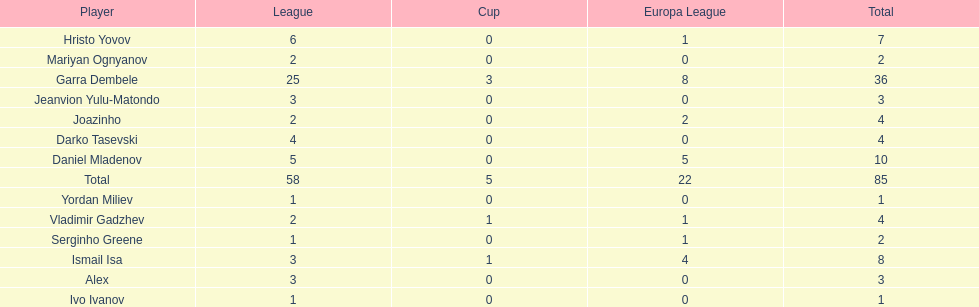Could you parse the entire table as a dict? {'header': ['Player', 'League', 'Cup', 'Europa League', 'Total'], 'rows': [['Hristo Yovov', '6', '0', '1', '7'], ['Mariyan Ognyanov', '2', '0', '0', '2'], ['Garra Dembele', '25', '3', '8', '36'], ['Jeanvion Yulu-Matondo', '3', '0', '0', '3'], ['Joazinho', '2', '0', '2', '4'], ['Darko Tasevski', '4', '0', '0', '4'], ['Daniel Mladenov', '5', '0', '5', '10'], ['Total', '58', '5', '22', '85'], ['Yordan Miliev', '1', '0', '0', '1'], ['Vladimir Gadzhev', '2', '1', '1', '4'], ['Serginho Greene', '1', '0', '1', '2'], ['Ismail Isa', '3', '1', '4', '8'], ['Alex', '3', '0', '0', '3'], ['Ivo Ivanov', '1', '0', '0', '1']]} Which player is in the same league as joazinho and vladimir gadzhev? Mariyan Ognyanov. 